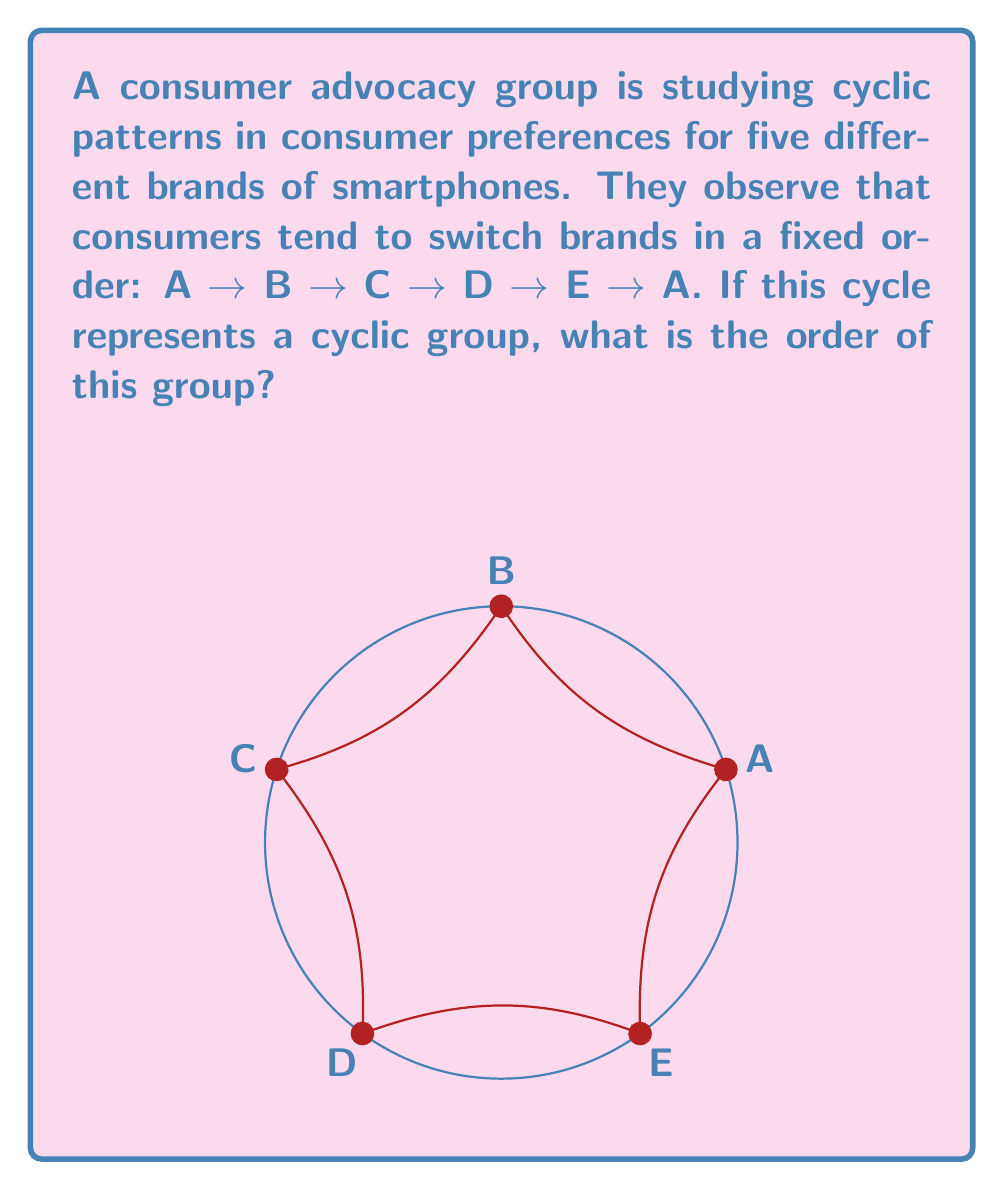What is the answer to this math problem? To determine the order of this cyclic group, we need to follow these steps:

1) In group theory, the order of a cyclic group is the number of distinct elements in the group.

2) In this case, each element of the group represents a complete rotation through the preference cycle.

3) Let's denote the generator of this group as $g$. Then the elements of the group are:
   $e$ (identity), $g$, $g^2$, $g^3$, $g^4$, ...

4) $g$ represents one complete cycle: A → B → C → D → E → A

5) $g^2$ would represent two complete cycles: A → B → C → D → E → A → B → C → D → E → A

6) We need to find the smallest positive integer $n$ such that $g^n = e$ (returns to the starting point)

7) In this case, after 5 applications of $g$, we return to the starting point:
   $g^5 = $ (A → B → C → D → E → A) × 5 = A → A = e$

8) Therefore, the smallest such $n$ is 5.

9) This means there are 5 distinct elements in the group: $e$, $g$, $g^2$, $g^3$, $g^4$

Thus, the order of this cyclic group is 5.
Answer: 5 